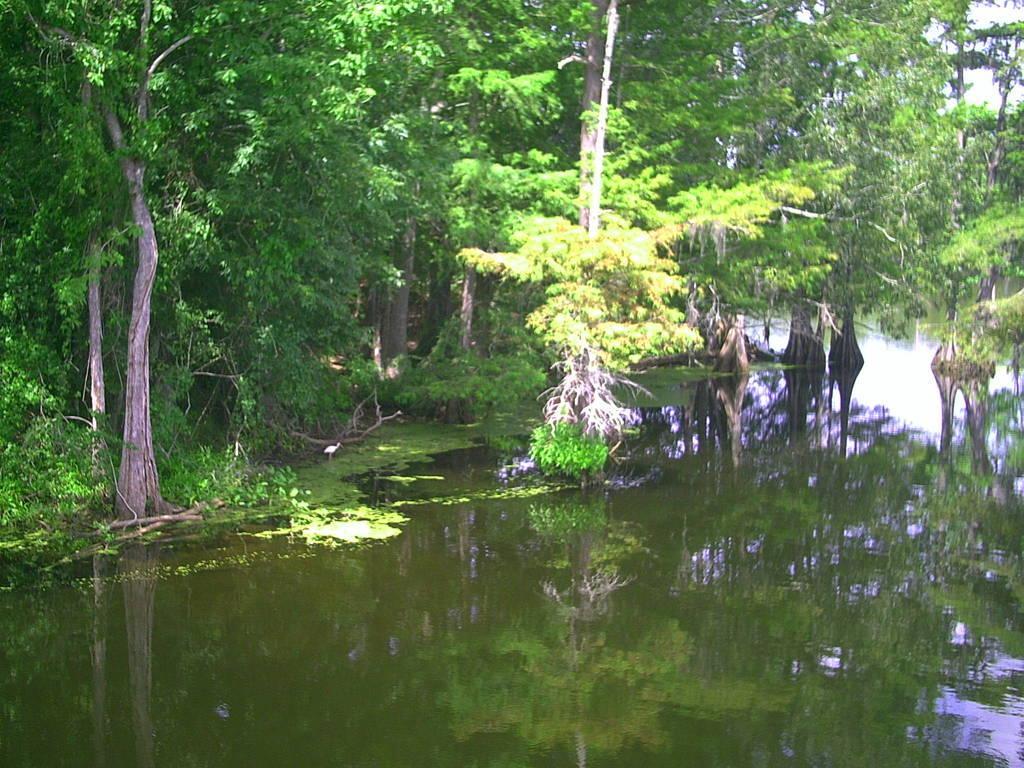Describe this image in one or two sentences. This picture is clicked outside. In the foreground we can see a water body and there are some objects in the water body. In the background we can see the plants, trees and some other objects. 